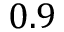Convert formula to latex. <formula><loc_0><loc_0><loc_500><loc_500>0 . 9</formula> 